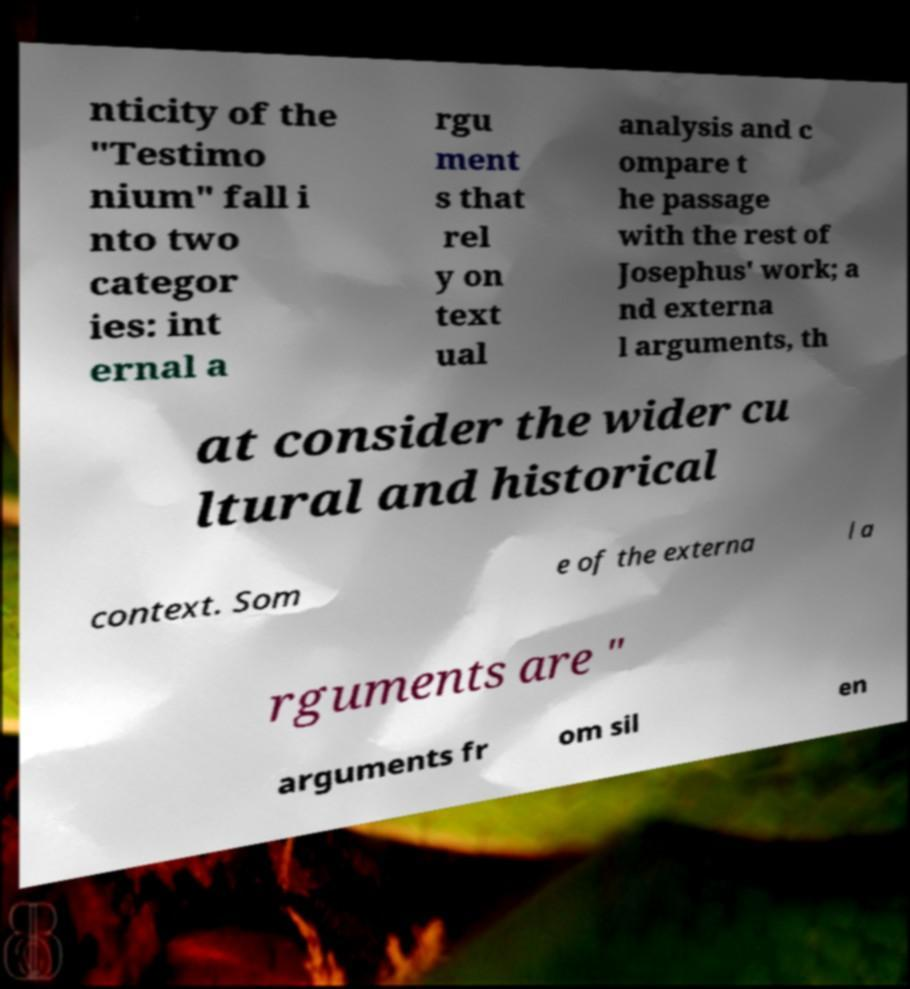Please read and relay the text visible in this image. What does it say? nticity of the "Testimo nium" fall i nto two categor ies: int ernal a rgu ment s that rel y on text ual analysis and c ompare t he passage with the rest of Josephus' work; a nd externa l arguments, th at consider the wider cu ltural and historical context. Som e of the externa l a rguments are " arguments fr om sil en 